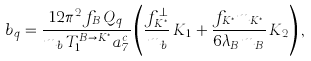<formula> <loc_0><loc_0><loc_500><loc_500>b _ { q } = \frac { 1 2 \pi ^ { 2 } f _ { B } \, Q _ { q } } { m _ { b } \, T _ { 1 } ^ { B \to K ^ { * } } a _ { 7 } ^ { c } } \left ( \frac { f _ { K ^ { * } } ^ { \perp } } { m _ { b } } \, K _ { 1 } + \frac { f _ { K ^ { * } } m _ { K ^ { * } } } { 6 \lambda _ { B } m _ { B } } \, K _ { 2 } \right ) ,</formula> 